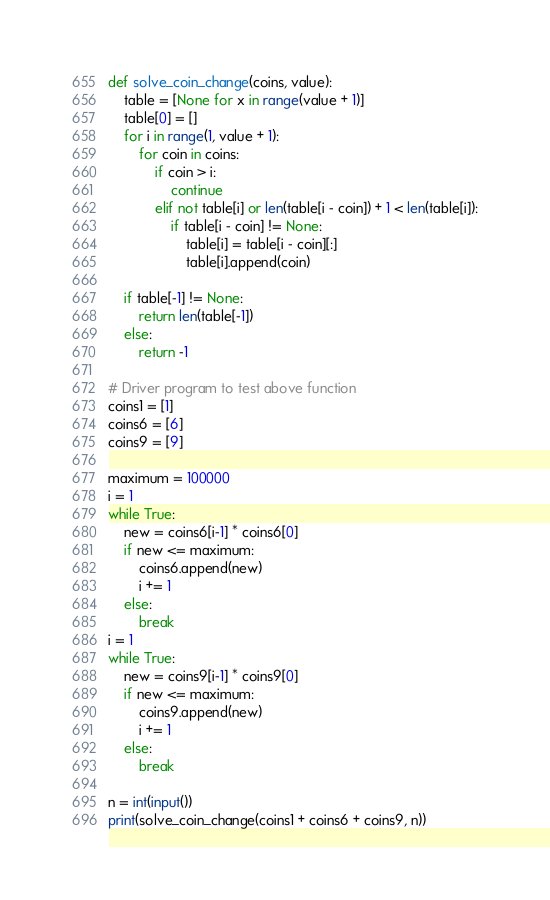Convert code to text. <code><loc_0><loc_0><loc_500><loc_500><_Python_>def solve_coin_change(coins, value):
    table = [None for x in range(value + 1)]
    table[0] = []
    for i in range(1, value + 1):
        for coin in coins:
            if coin > i: 
                continue
            elif not table[i] or len(table[i - coin]) + 1 < len(table[i]):
                if table[i - coin] != None:
                    table[i] = table[i - coin][:]
                    table[i].append(coin)

    if table[-1] != None:
        return len(table[-1])
    else:
        return -1      

# Driver program to test above function
coins1 = [1]
coins6 = [6]
coins9 = [9]

maximum = 100000
i = 1
while True:
    new = coins6[i-1] * coins6[0]
    if new <= maximum:
        coins6.append(new)
        i += 1
    else:
        break
i = 1
while True:
    new = coins9[i-1] * coins9[0]
    if new <= maximum:
        coins9.append(new)
        i += 1
    else:
        break

n = int(input())
print(solve_coin_change(coins1 + coins6 + coins9, n))</code> 